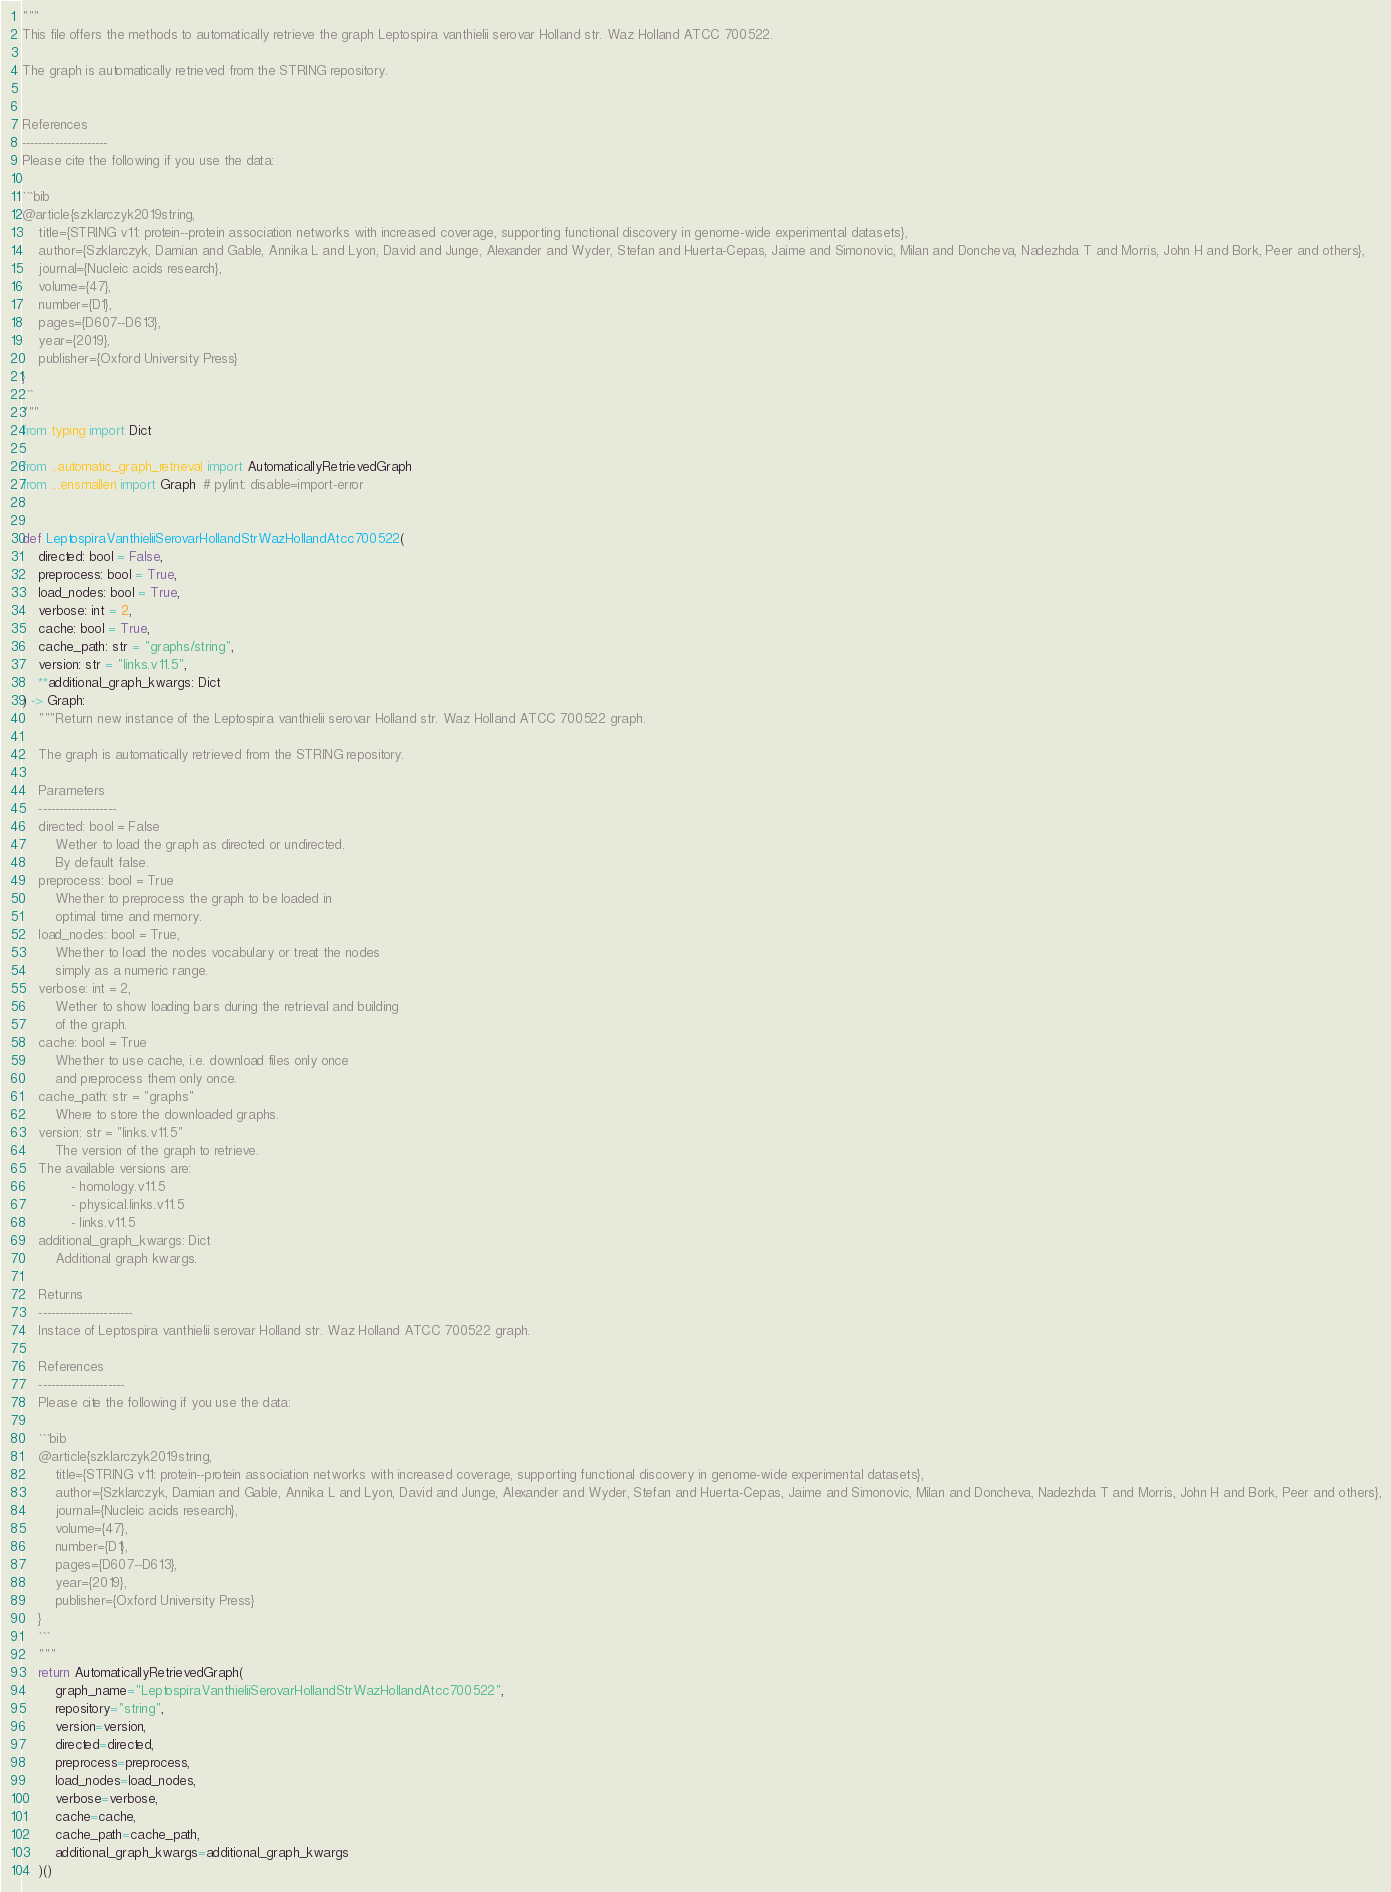Convert code to text. <code><loc_0><loc_0><loc_500><loc_500><_Python_>"""
This file offers the methods to automatically retrieve the graph Leptospira vanthielii serovar Holland str. Waz Holland ATCC 700522.

The graph is automatically retrieved from the STRING repository. 


References
---------------------
Please cite the following if you use the data:

```bib
@article{szklarczyk2019string,
    title={STRING v11: protein--protein association networks with increased coverage, supporting functional discovery in genome-wide experimental datasets},
    author={Szklarczyk, Damian and Gable, Annika L and Lyon, David and Junge, Alexander and Wyder, Stefan and Huerta-Cepas, Jaime and Simonovic, Milan and Doncheva, Nadezhda T and Morris, John H and Bork, Peer and others},
    journal={Nucleic acids research},
    volume={47},
    number={D1},
    pages={D607--D613},
    year={2019},
    publisher={Oxford University Press}
}
```
"""
from typing import Dict

from ..automatic_graph_retrieval import AutomaticallyRetrievedGraph
from ...ensmallen import Graph  # pylint: disable=import-error


def LeptospiraVanthieliiSerovarHollandStrWazHollandAtcc700522(
    directed: bool = False,
    preprocess: bool = True,
    load_nodes: bool = True,
    verbose: int = 2,
    cache: bool = True,
    cache_path: str = "graphs/string",
    version: str = "links.v11.5",
    **additional_graph_kwargs: Dict
) -> Graph:
    """Return new instance of the Leptospira vanthielii serovar Holland str. Waz Holland ATCC 700522 graph.

    The graph is automatically retrieved from the STRING repository.	

    Parameters
    -------------------
    directed: bool = False
        Wether to load the graph as directed or undirected.
        By default false.
    preprocess: bool = True
        Whether to preprocess the graph to be loaded in 
        optimal time and memory.
    load_nodes: bool = True,
        Whether to load the nodes vocabulary or treat the nodes
        simply as a numeric range.
    verbose: int = 2,
        Wether to show loading bars during the retrieval and building
        of the graph.
    cache: bool = True
        Whether to use cache, i.e. download files only once
        and preprocess them only once.
    cache_path: str = "graphs"
        Where to store the downloaded graphs.
    version: str = "links.v11.5"
        The version of the graph to retrieve.		
	The available versions are:
			- homology.v11.5
			- physical.links.v11.5
			- links.v11.5
    additional_graph_kwargs: Dict
        Additional graph kwargs.

    Returns
    -----------------------
    Instace of Leptospira vanthielii serovar Holland str. Waz Holland ATCC 700522 graph.

	References
	---------------------
	Please cite the following if you use the data:
	
	```bib
	@article{szklarczyk2019string,
	    title={STRING v11: protein--protein association networks with increased coverage, supporting functional discovery in genome-wide experimental datasets},
	    author={Szklarczyk, Damian and Gable, Annika L and Lyon, David and Junge, Alexander and Wyder, Stefan and Huerta-Cepas, Jaime and Simonovic, Milan and Doncheva, Nadezhda T and Morris, John H and Bork, Peer and others},
	    journal={Nucleic acids research},
	    volume={47},
	    number={D1},
	    pages={D607--D613},
	    year={2019},
	    publisher={Oxford University Press}
	}
	```
    """
    return AutomaticallyRetrievedGraph(
        graph_name="LeptospiraVanthieliiSerovarHollandStrWazHollandAtcc700522",
        repository="string",
        version=version,
        directed=directed,
        preprocess=preprocess,
        load_nodes=load_nodes,
        verbose=verbose,
        cache=cache,
        cache_path=cache_path,
        additional_graph_kwargs=additional_graph_kwargs
    )()
</code> 